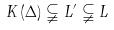<formula> <loc_0><loc_0><loc_500><loc_500>K \left ( \Delta \right ) \subsetneqq L ^ { \prime } \subsetneqq L</formula> 